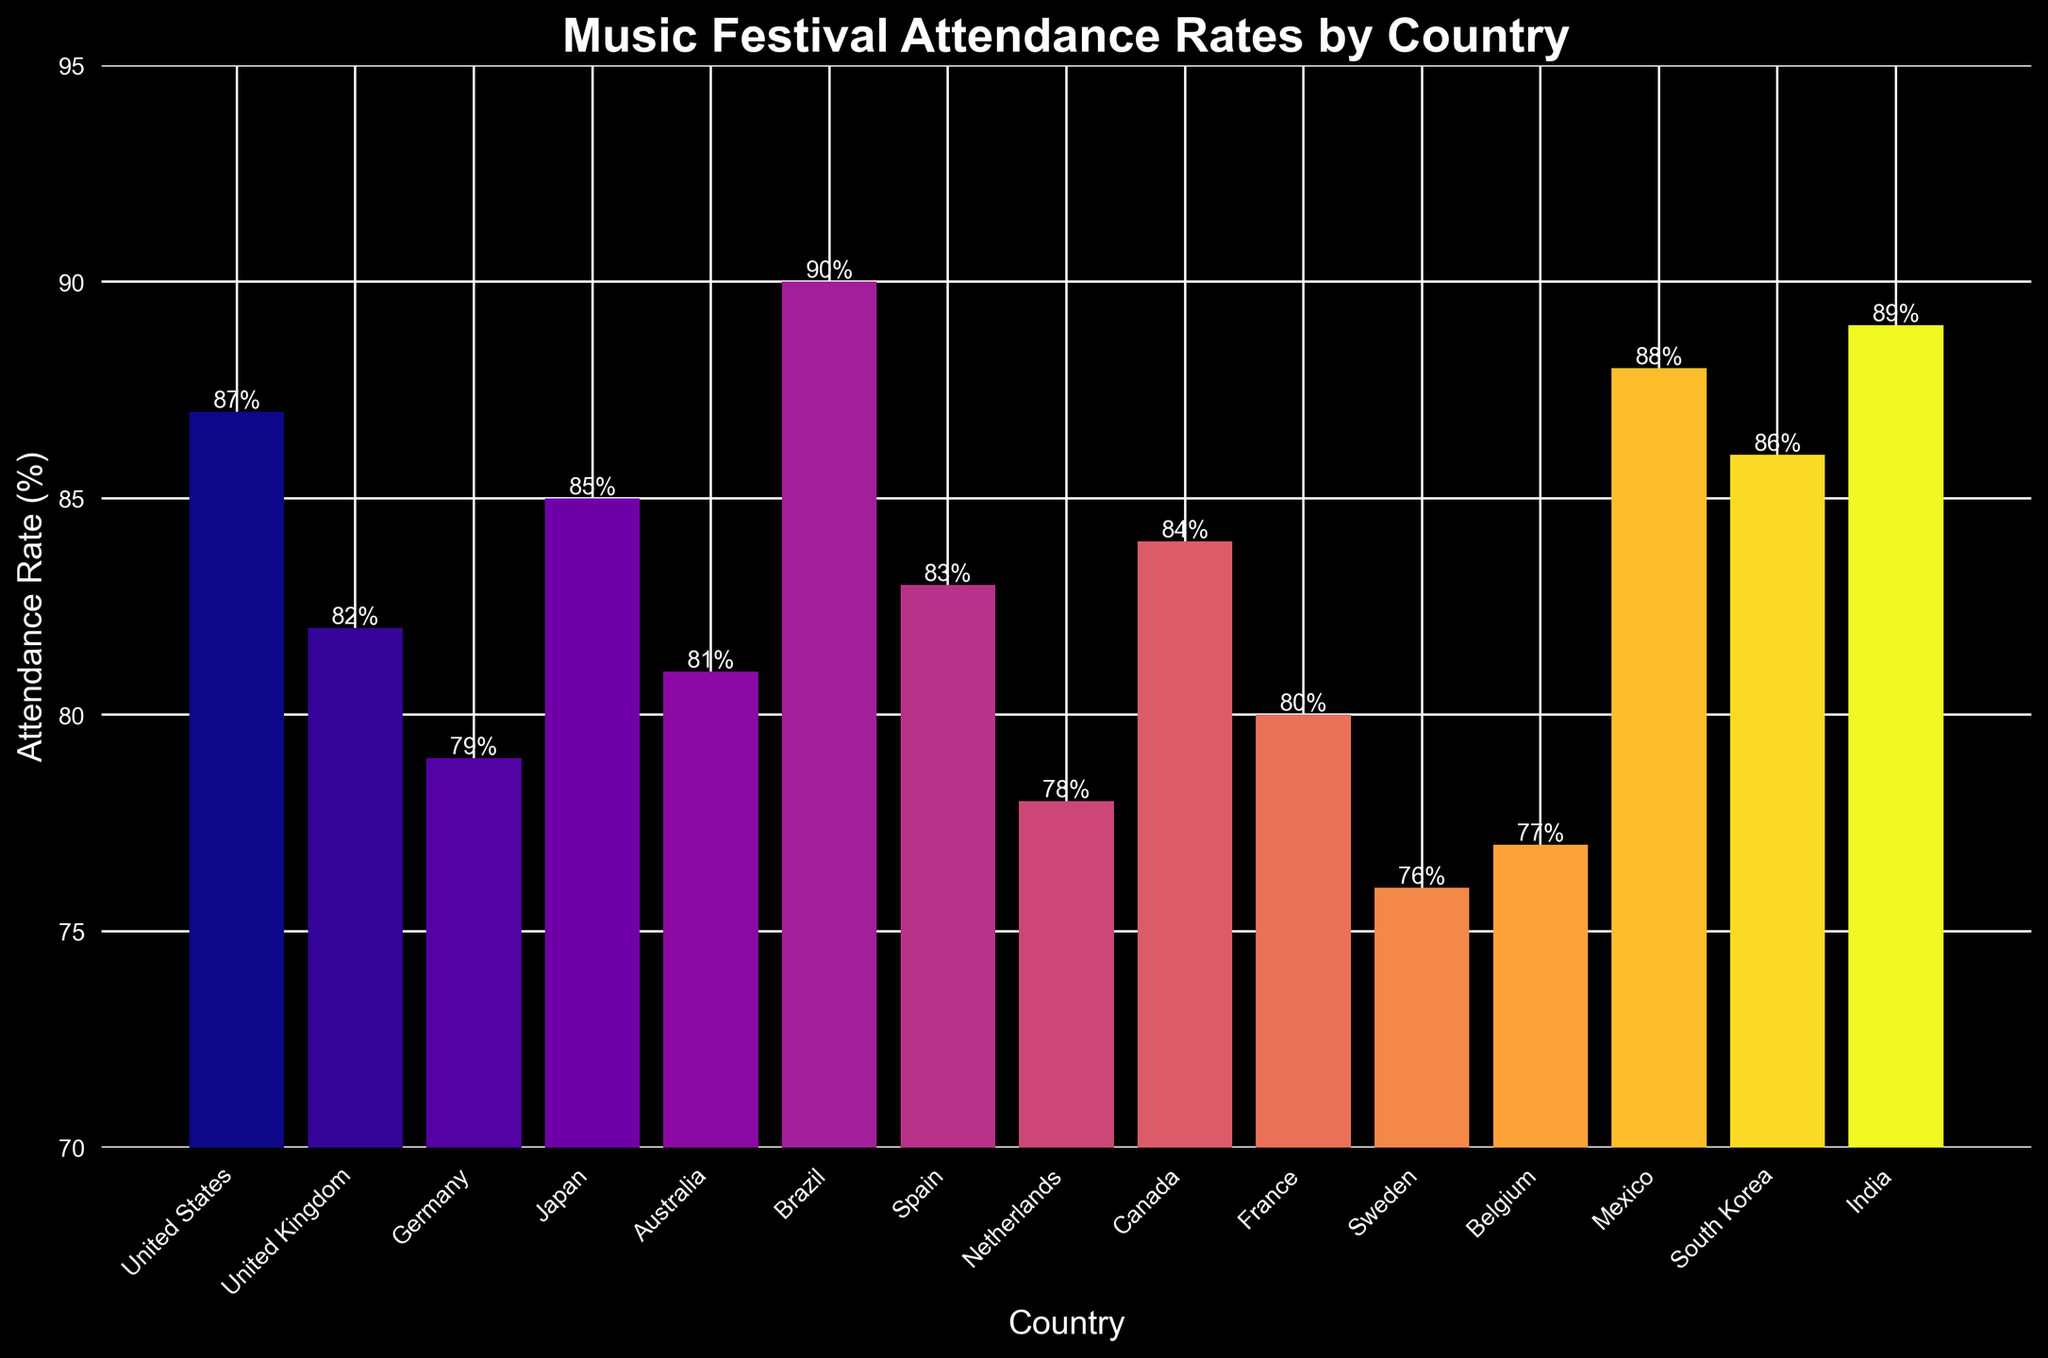What's the country with the highest music festival attendance rate? First, identify the highest bar visually on the chart, which is the tallest one. Upon observing, you can see that Brazil has the highest attendance rate at 90%.
Answer: Brazil What's the difference in attendance rates between the country with the highest and the country with the lowest attendance rates? Identify the highest and lowest attendance rates visually. The highest is 90% (Brazil), and the lowest is 76% (Sweden). Calculate the difference: 90% - 76% = 14%.
Answer: 14% Which countries have attendance rates above 85%? Observe the chart and locate bars that exceed the 85% mark. Those countries are United States (87%), Japan (85%), South Korea (86%), Mexico (88%), and India (89%).
Answer: United States, Japan, South Korea, Mexico, India How many countries have an attendance rate between 80% and 85%? Find the bars that fall within the 80% to 85% range. The countries are United Kingdom (82%), Australia (81%), Spain (83%), Canada (84%), and France (80%). Count these countries: 5.
Answer: 5 What is the average attendance rate of the countries displayed? Sum all attendance rates and divide by the number of countries. The sum is 87+82+79+85+81+90+83+78+84+80+76+77+88+86+89 = 1205. Divide by 15 countries: 1205/15 = 80.3%
Answer: 80.3% Which country has an attendance rate equal to or lower than Belgium? Find Belgium in the chart with a 77% rate. Look for countries with rates <= 77%. Sweden (76%) fits the condition.
Answer: Sweden Which country has a higher attendance rate, France or Netherlands? Compare the bars for France and Netherlands. France is at 80%, while Netherlands is at 78%. France has a higher rate.
Answer: France What's the range of attendance rates displayed on the chart? Find the highest and lowest attendance rates. Highest: Brazil (90%), Lowest: Sweden (76%). Calculate the range: 90% - 76% = 14%.
Answer: 14% If we consider only the top 5 countries by attendance rate, what is their average attendance rate? Identify the top 5 countries: Brazil (90%), India (89%), Mexico (88%), United States (87%), and South Korea (86%). Calculate their average: (90 + 89 + 88 + 87 + 86) / 5 = 88%.
Answer: 88% How does the attendance rate of Germany compare to that of Spain? Compare the bars for Germany (79%) and Spain (83%). Spain has a higher attendance rate than Germany.
Answer: Spain 